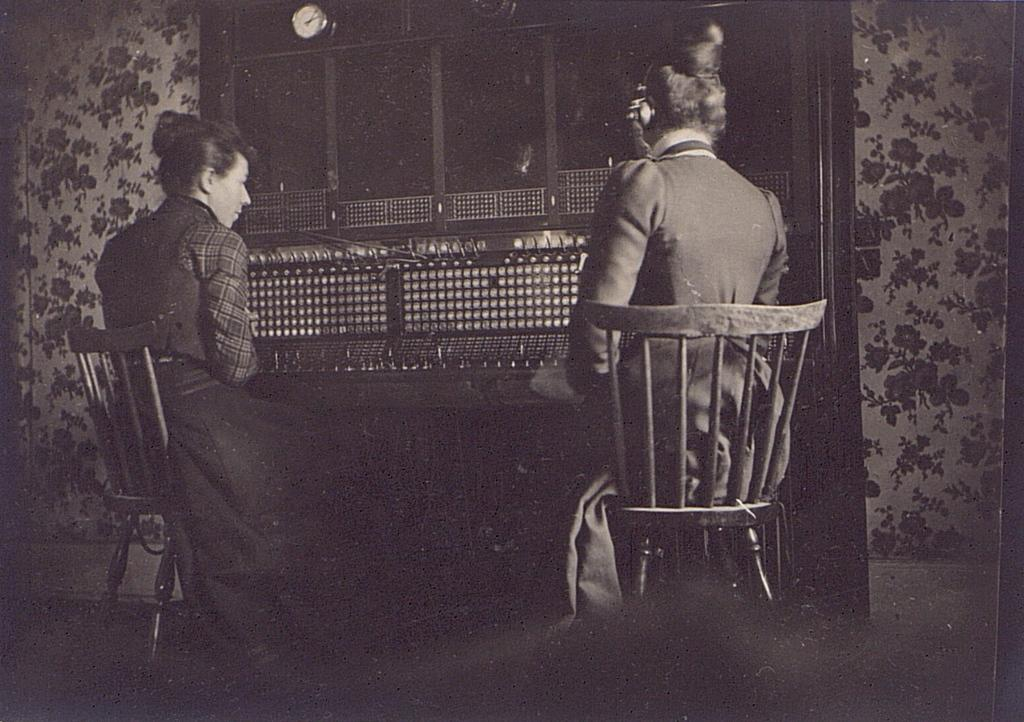How many people are seated in the image? There are two persons seated in the image. What is one person wearing on their head? One person is wearing a headset over their ear. What object is present in front of the seated persons? A watch is present in front of the seated persons. What type of window treatment can be seen in the image? There are curtains visible in the image. What type of mitten is being used to stir the minute in the image? There is no mitten or stirring activity present in the image. How many whips can be seen in the image? There are no whips present in the image. 